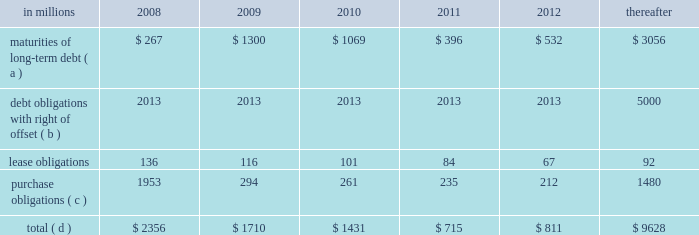Exchanged installment notes totaling approximately $ 4.8 billion and approximately $ 400 million of inter- national paper promissory notes for interests in enti- ties formed to monetize the notes .
International paper determined that it was not the primary benefi- ciary of these entities , and therefore should not consolidate its investments in these entities .
During 2006 , these entities acquired an additional $ 4.8 bil- lion of international paper debt securities for cash , resulting in a total of approximately $ 5.2 billion of international paper debt obligations held by these entities at december 31 , 2006 .
Since international paper has , and intends to affect , a legal right to offset its obligations under these debt instruments with its investments in the entities , international paper has offset $ 5.0 billion of interest in the entities against $ 5.0 billion of international paper debt obligations held by the entities as of december 31 , 2007 .
International paper also holds variable interests in two financing entities that were used to monetize long-term notes received from sales of forestlands in 2002 and 2001 .
See note 8 of the notes to consolidated financial statements in item 8 .
Financial statements and supplementary data for a further discussion of these transactions .
Capital resources outlook for 2008 international paper expects to be able to meet pro- jected capital expenditures , service existing debt and meet working capital and dividend requirements during 2008 through current cash balances and cash from operations , supplemented as required by its various existing credit facilities .
International paper has approximately $ 2.5 billion of committed bank credit agreements , which management believes is adequate to cover expected operating cash flow variability during our industry 2019s economic cycles .
The agreements generally provide for interest rates at a floating rate index plus a pre-determined margin dependent upon international paper 2019s credit rating .
The agreements include a $ 1.5 billion fully commit- ted revolving bank credit agreement that expires in march 2011 and has a facility fee of 0.10% ( 0.10 % ) payable quarterly .
These agreements also include up to $ 1.0 billion of available commercial paper-based financ- ings under a receivables securitization program that expires in october 2009 with a facility fee of 0.10% ( 0.10 % ) .
At december 31 , 2007 , there were no borrowings under either the bank credit agreements or receiv- ables securitization program .
The company will continue to rely upon debt and capital markets for the majority of any necessary long-term funding not provided by operating cash flows .
Funding decisions will be guided by our capi- tal structure planning objectives .
The primary goals of the company 2019s capital structure planning are to maximize financial flexibility and preserve liquidity while reducing interest expense .
The majority of international paper 2019s debt is accessed through global public capital markets where we have a wide base of investors .
The company was in compliance with all its debt covenants at december 31 , 2007 .
Principal financial covenants include maintenance of a minimum net worth , defined as the sum of common stock , paid-in capital and retained earnings , less treasury stock , plus any goodwill impairment charges , of $ 9 billion ; and a maximum total debt to capital ratio , defined as total debt divided by total debt plus net worth , of 60% ( 60 % ) .
Maintaining an investment grade credit rating is an important element of international paper 2019s financing strategy .
At december 31 , 2007 , the company held long-term credit ratings of bbb ( stable outlook ) and baa3 ( stable outlook ) by standard & poor 2019s ( s&p ) and moody 2019s investor services ( moody 2019s ) , respectively .
The company currently has short-term credit ratings by s&p and moody 2019s of a-2 and p-3 , respectively .
Contractual obligations for future payments under existing debt and lease commitments and purchase obligations at december 31 , 2007 , were as follows : in millions 2008 2009 2010 2011 2012 thereafter maturities of long-term debt ( a ) $ 267 $ 1300 $ 1069 $ 396 $ 532 $ 3056 debt obligations with right of offset ( b ) 2013 2013 2013 2013 2013 5000 .
( a ) total debt includes scheduled principal payments only .
( b ) represents debt obligations borrowed from non-consolidated variable interest entities for which international paper has , and intends to affect , a legal right to offset these obligations with investments held in the entities .
Accordingly , in its con- solidated balance sheet at december 31 , 2007 , international paper has offset approximately $ 5.0 billion of interests in the entities against this $ 5.0 billion of debt obligations held by the entities ( see note 8 in the accompanying consolidated financial statements ) .
( c ) includes $ 2.1 billion relating to fiber supply agreements entered into at the time of the transformation plan forestland sales .
( d ) not included in the above table are unrecognized tax benefits of approximately $ 280 million. .
During 2006 what was the initial debt balance prior to the issuance of additional international paper debt securities for cash? 
Computations: (5.2 - 4.8)
Answer: 0.4. 